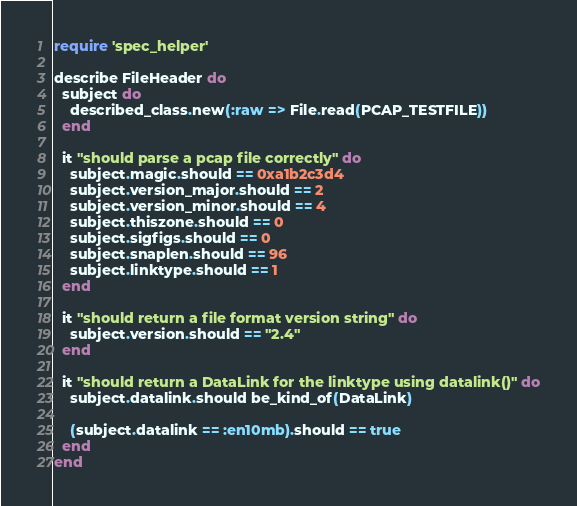Convert code to text. <code><loc_0><loc_0><loc_500><loc_500><_Ruby_>require 'spec_helper'

describe FileHeader do
  subject do
    described_class.new(:raw => File.read(PCAP_TESTFILE))
  end

  it "should parse a pcap file correctly" do
    subject.magic.should == 0xa1b2c3d4
    subject.version_major.should == 2
    subject.version_minor.should == 4
    subject.thiszone.should == 0
    subject.sigfigs.should == 0
    subject.snaplen.should == 96
    subject.linktype.should == 1
  end

  it "should return a file format version string" do
    subject.version.should == "2.4"
  end

  it "should return a DataLink for the linktype using datalink()" do
    subject.datalink.should be_kind_of(DataLink)

    (subject.datalink == :en10mb).should == true
  end
end
</code> 